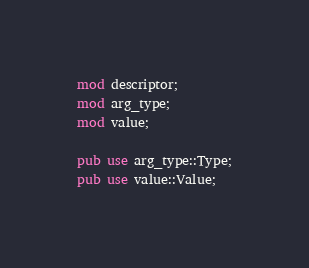<code> <loc_0><loc_0><loc_500><loc_500><_Rust_>mod descriptor;
mod arg_type;
mod value;

pub use arg_type::Type;
pub use value::Value;</code> 